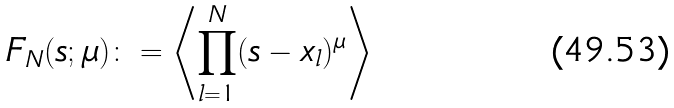Convert formula to latex. <formula><loc_0><loc_0><loc_500><loc_500>F _ { N } ( s ; \mu ) \colon = \left \langle \prod _ { l = 1 } ^ { N } ( s - x _ { l } ) ^ { \mu } \right \rangle</formula> 